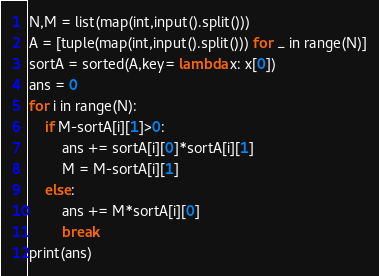<code> <loc_0><loc_0><loc_500><loc_500><_Python_>N,M = list(map(int,input().split()))
A = [tuple(map(int,input().split())) for _ in range(N)]
sortA = sorted(A,key= lambda x: x[0])
ans = 0
for i in range(N):
    if M-sortA[i][1]>0:
        ans += sortA[i][0]*sortA[i][1]
        M = M-sortA[i][1]
    else:
        ans += M*sortA[i][0]
        break
print(ans)</code> 